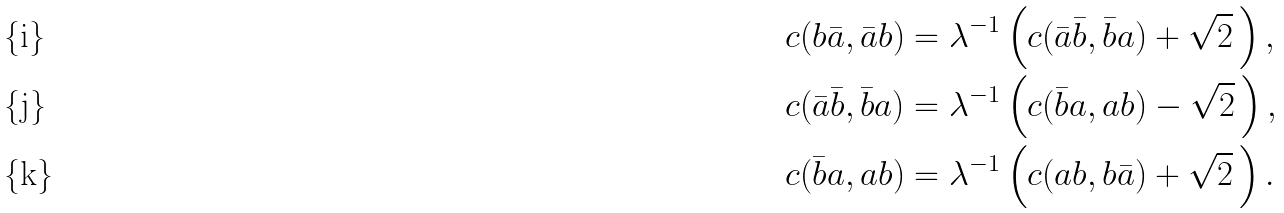Convert formula to latex. <formula><loc_0><loc_0><loc_500><loc_500>c ( b \bar { a } , \bar { a } b ) & = \lambda ^ { - 1 } \left ( c ( \bar { a } \bar { b } , \bar { b } a ) + \sqrt { 2 } \, \right ) , \\ c ( \bar { a } \bar { b } , \bar { b } a ) & = \lambda ^ { - 1 } \left ( c ( \bar { b } a , a b ) - \sqrt { 2 } \, \right ) , \\ c ( \bar { b } a , a b ) & = \lambda ^ { - 1 } \left ( c ( a b , b \bar { a } ) + \sqrt { 2 } \, \right ) .</formula> 